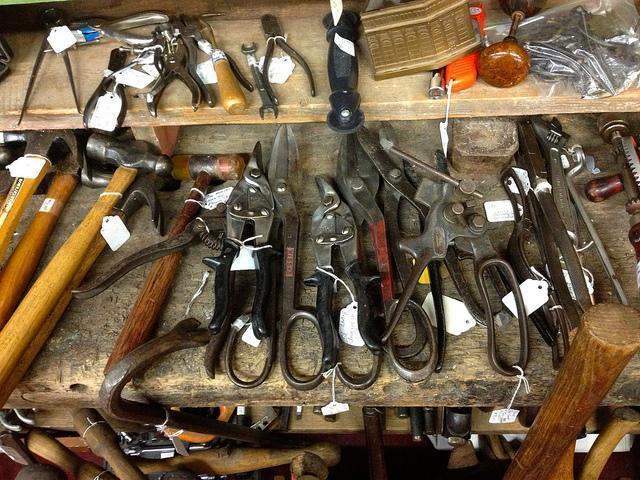Where would these tools be found?
Choose the correct response and explain in the format: 'Answer: answer
Rationale: rationale.'
Options: Kitchen, store, trunk, street. Answer: store.
Rationale: The tools are in a store. 